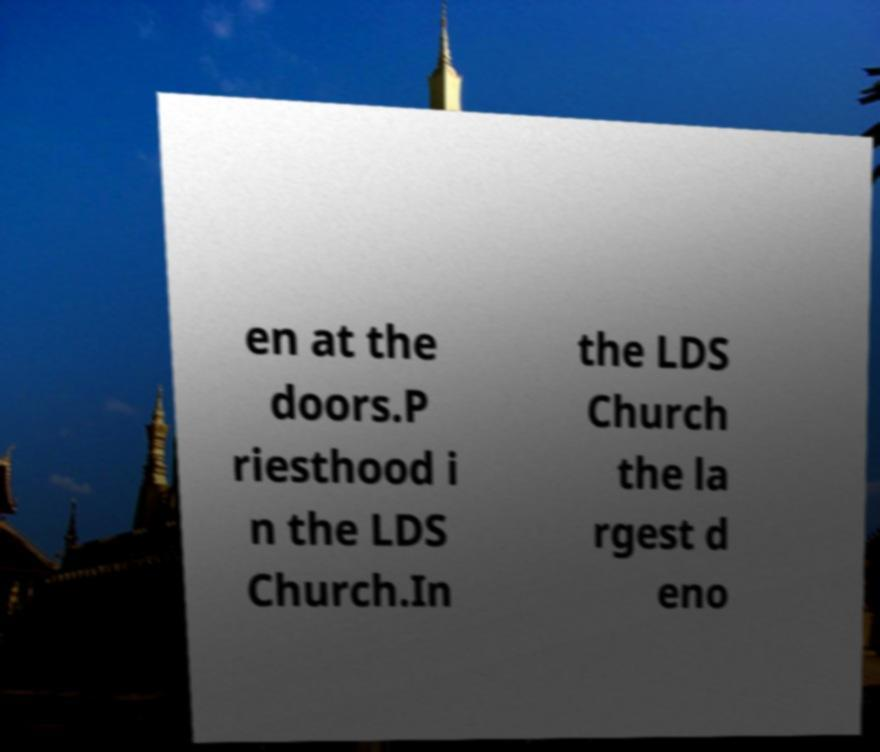Could you assist in decoding the text presented in this image and type it out clearly? en at the doors.P riesthood i n the LDS Church.In the LDS Church the la rgest d eno 